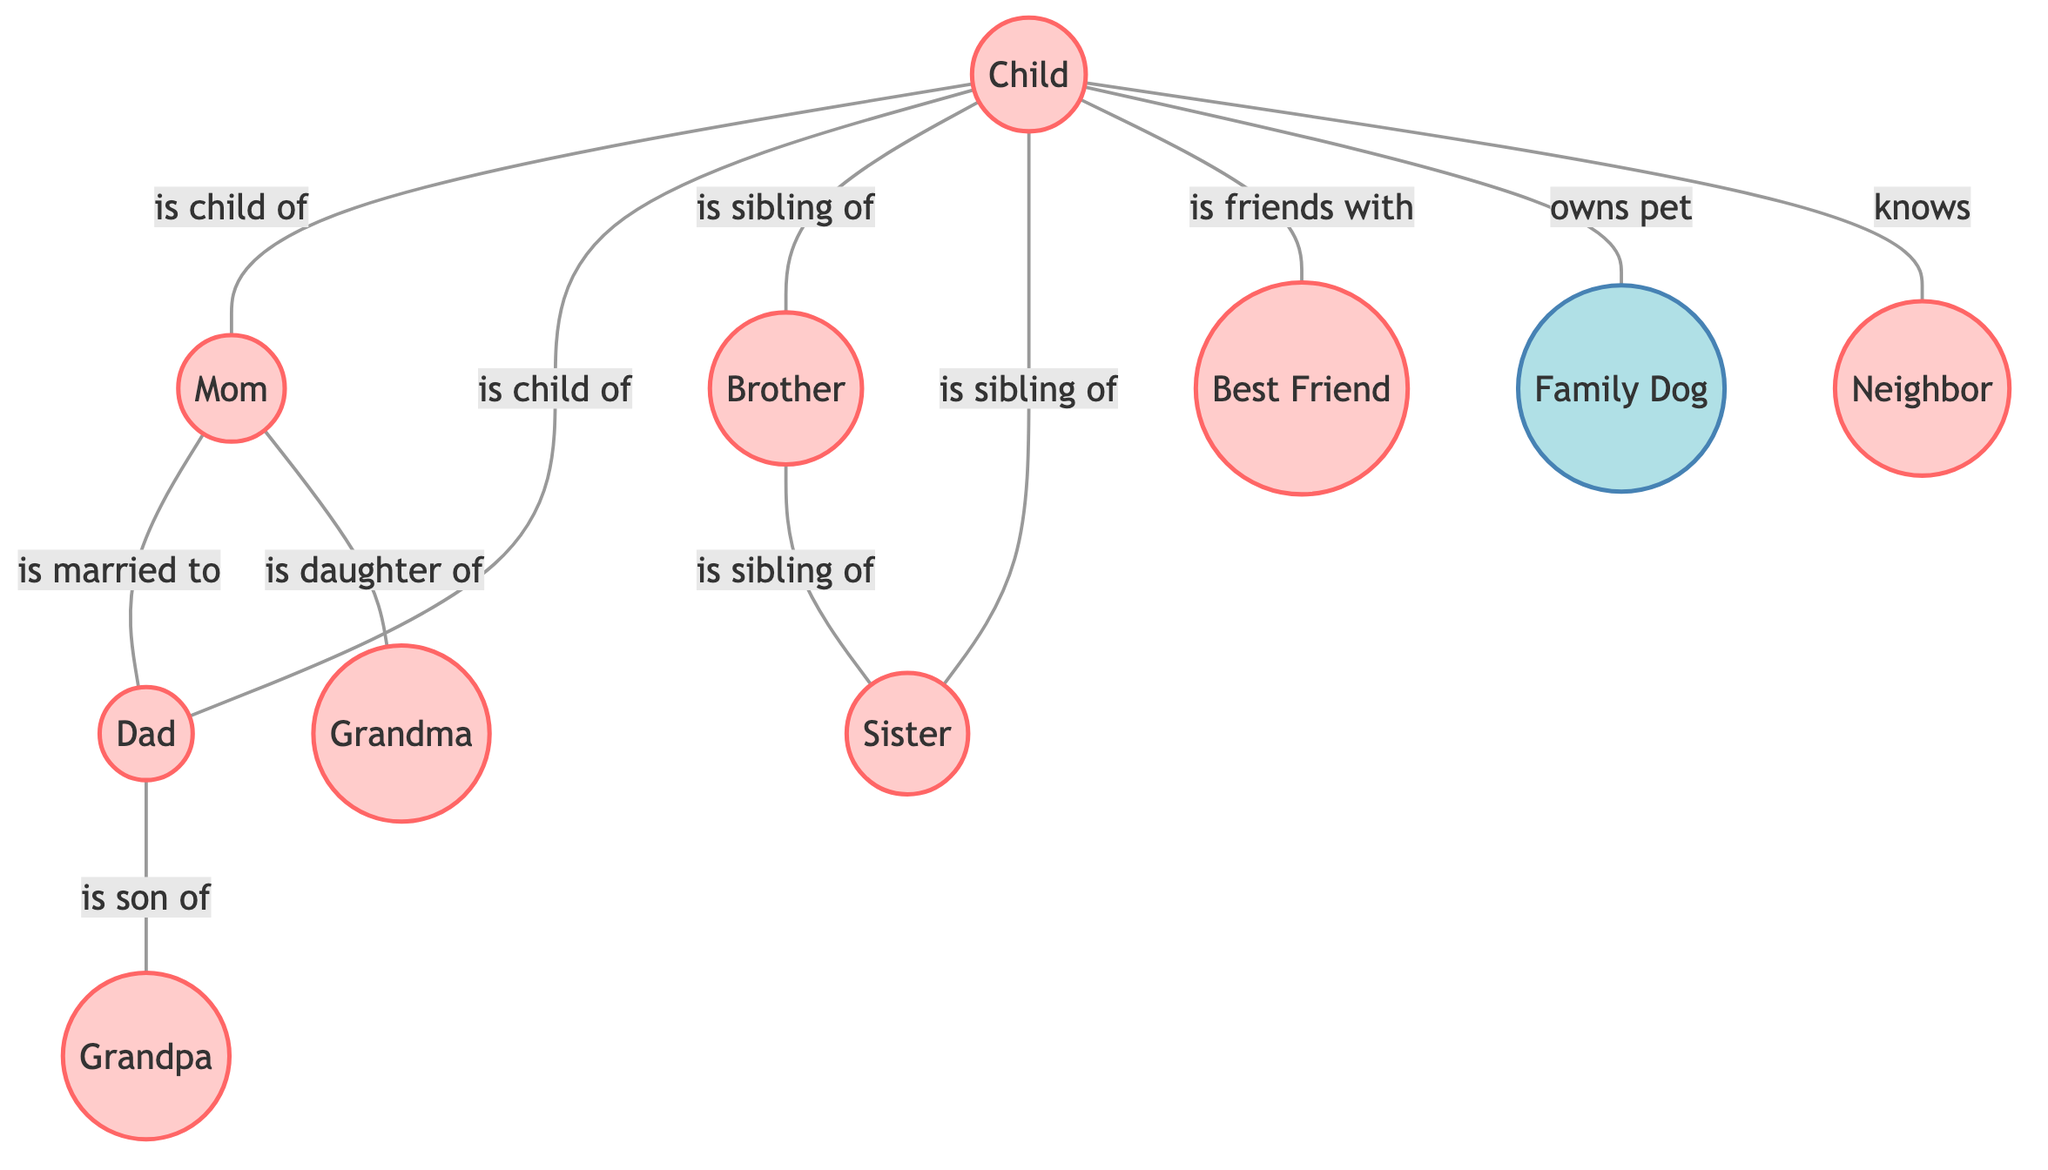What's the total number of people in the diagram? The diagram has 10 nodes, and out of those, 9 nodes represent people (Child, Mom, Dad, Brother, Sister, Grandma, Grandpa, Best Friend, Neighbor), while one represents a pet (Family Dog). Hence, the total number of people is 9.
Answer: 9 Who is the sibling of the Child? The Child is connected to the Brother and Sister with the relationship "is sibling of." This means both Brother and Sister are siblings of the Child.
Answer: Brother and Sister Who is the Mom married to? The diagram shows a connection between Mom and Dad labeled "is married to." This tells us that Mom is married to Dad.
Answer: Dad How many siblings does the Child have? The diagram indicates two connections where the Child is a sibling of Brother and Sister. Therefore, the Child has 2 siblings.
Answer: 2 Who is the Child's pet? The connection "owns pet" shows that the Child is linked to the Family Dog. This means the pet of the Child is the Family Dog.
Answer: Family Dog Who is Grandma's daughter? The diagram applies the relationship "is daughter of" for Grandma, which connects her to Mom. This signifies that Grandma's daughter is Mom.
Answer: Mom What type of relationship does the Child have with the Best Friend? The diagram connects the Child to Best Friend with the relationship "is friends with". Therefore, the relationship is friendship.
Answer: friendship How many direct connections does the Child have? The Child has connections to Mom, Dad, Brother, Sister, Best Friend, Family Dog, and Neighbor, which totals 7 direct connections.
Answer: 7 Who is Grandpa's son? The diagram illustrates a connection "is son of" for Dad, linking him to Grandpa. Hence, Grandpa's son is Dad.
Answer: Dad 